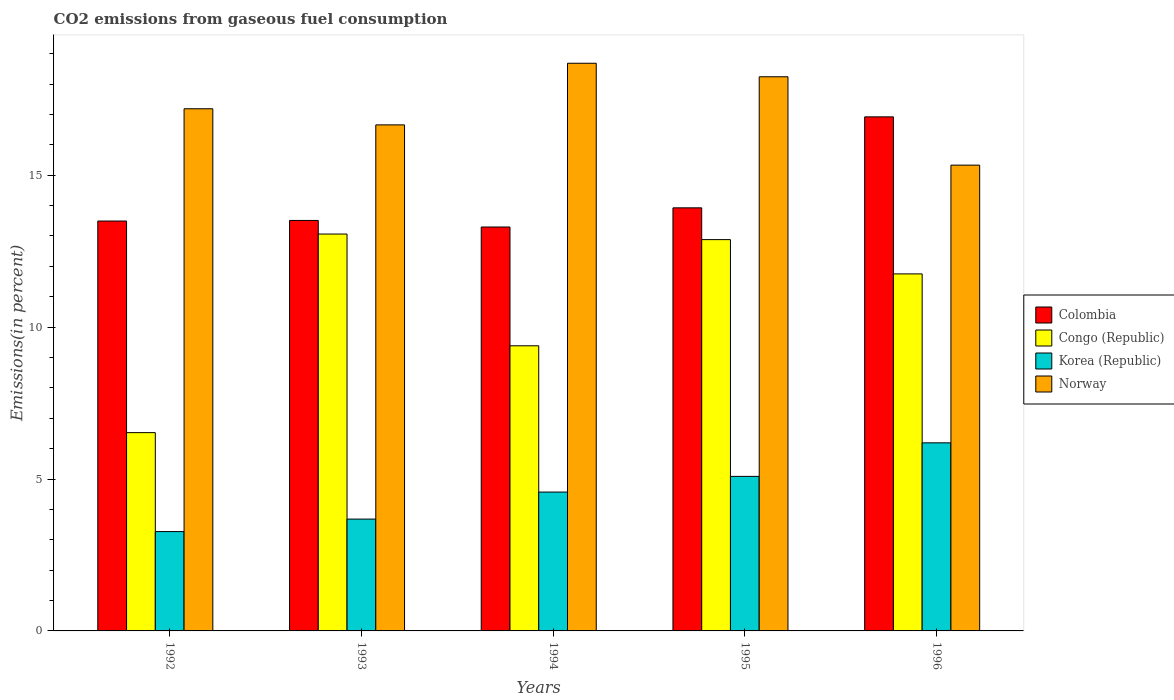How many groups of bars are there?
Provide a short and direct response. 5. Are the number of bars per tick equal to the number of legend labels?
Provide a short and direct response. Yes. How many bars are there on the 5th tick from the right?
Make the answer very short. 4. What is the total CO2 emitted in Congo (Republic) in 1995?
Provide a succinct answer. 12.88. Across all years, what is the maximum total CO2 emitted in Norway?
Offer a terse response. 18.69. Across all years, what is the minimum total CO2 emitted in Colombia?
Your response must be concise. 13.3. In which year was the total CO2 emitted in Norway maximum?
Give a very brief answer. 1994. What is the total total CO2 emitted in Korea (Republic) in the graph?
Your answer should be compact. 22.8. What is the difference between the total CO2 emitted in Colombia in 1992 and that in 1996?
Provide a short and direct response. -3.43. What is the difference between the total CO2 emitted in Korea (Republic) in 1996 and the total CO2 emitted in Colombia in 1994?
Your response must be concise. -7.1. What is the average total CO2 emitted in Colombia per year?
Make the answer very short. 14.23. In the year 1992, what is the difference between the total CO2 emitted in Congo (Republic) and total CO2 emitted in Colombia?
Your answer should be very brief. -6.97. What is the ratio of the total CO2 emitted in Norway in 1992 to that in 1995?
Ensure brevity in your answer.  0.94. What is the difference between the highest and the second highest total CO2 emitted in Congo (Republic)?
Ensure brevity in your answer.  0.18. What is the difference between the highest and the lowest total CO2 emitted in Norway?
Ensure brevity in your answer.  3.35. Is the sum of the total CO2 emitted in Congo (Republic) in 1992 and 1994 greater than the maximum total CO2 emitted in Korea (Republic) across all years?
Your answer should be compact. Yes. Is it the case that in every year, the sum of the total CO2 emitted in Colombia and total CO2 emitted in Norway is greater than the sum of total CO2 emitted in Korea (Republic) and total CO2 emitted in Congo (Republic)?
Your response must be concise. No. What does the 3rd bar from the left in 1994 represents?
Offer a terse response. Korea (Republic). What does the 2nd bar from the right in 1994 represents?
Provide a succinct answer. Korea (Republic). Is it the case that in every year, the sum of the total CO2 emitted in Congo (Republic) and total CO2 emitted in Korea (Republic) is greater than the total CO2 emitted in Norway?
Ensure brevity in your answer.  No. Does the graph contain any zero values?
Your answer should be very brief. No. Does the graph contain grids?
Your answer should be compact. No. Where does the legend appear in the graph?
Provide a succinct answer. Center right. How many legend labels are there?
Provide a short and direct response. 4. What is the title of the graph?
Your answer should be compact. CO2 emissions from gaseous fuel consumption. What is the label or title of the X-axis?
Provide a succinct answer. Years. What is the label or title of the Y-axis?
Offer a very short reply. Emissions(in percent). What is the Emissions(in percent) of Colombia in 1992?
Make the answer very short. 13.49. What is the Emissions(in percent) in Congo (Republic) in 1992?
Your answer should be compact. 6.53. What is the Emissions(in percent) in Korea (Republic) in 1992?
Offer a terse response. 3.27. What is the Emissions(in percent) of Norway in 1992?
Provide a succinct answer. 17.19. What is the Emissions(in percent) in Colombia in 1993?
Keep it short and to the point. 13.51. What is the Emissions(in percent) in Congo (Republic) in 1993?
Provide a succinct answer. 13.06. What is the Emissions(in percent) of Korea (Republic) in 1993?
Offer a very short reply. 3.68. What is the Emissions(in percent) in Norway in 1993?
Ensure brevity in your answer.  16.66. What is the Emissions(in percent) of Colombia in 1994?
Keep it short and to the point. 13.3. What is the Emissions(in percent) of Congo (Republic) in 1994?
Provide a succinct answer. 9.39. What is the Emissions(in percent) of Korea (Republic) in 1994?
Offer a terse response. 4.57. What is the Emissions(in percent) of Norway in 1994?
Your response must be concise. 18.69. What is the Emissions(in percent) of Colombia in 1995?
Provide a succinct answer. 13.93. What is the Emissions(in percent) of Congo (Republic) in 1995?
Your answer should be very brief. 12.88. What is the Emissions(in percent) of Korea (Republic) in 1995?
Keep it short and to the point. 5.09. What is the Emissions(in percent) of Norway in 1995?
Provide a short and direct response. 18.24. What is the Emissions(in percent) of Colombia in 1996?
Make the answer very short. 16.92. What is the Emissions(in percent) of Congo (Republic) in 1996?
Your answer should be compact. 11.75. What is the Emissions(in percent) in Korea (Republic) in 1996?
Provide a succinct answer. 6.19. What is the Emissions(in percent) in Norway in 1996?
Give a very brief answer. 15.33. Across all years, what is the maximum Emissions(in percent) in Colombia?
Keep it short and to the point. 16.92. Across all years, what is the maximum Emissions(in percent) of Congo (Republic)?
Ensure brevity in your answer.  13.06. Across all years, what is the maximum Emissions(in percent) of Korea (Republic)?
Make the answer very short. 6.19. Across all years, what is the maximum Emissions(in percent) of Norway?
Make the answer very short. 18.69. Across all years, what is the minimum Emissions(in percent) in Colombia?
Give a very brief answer. 13.3. Across all years, what is the minimum Emissions(in percent) of Congo (Republic)?
Offer a terse response. 6.53. Across all years, what is the minimum Emissions(in percent) in Korea (Republic)?
Provide a succinct answer. 3.27. Across all years, what is the minimum Emissions(in percent) of Norway?
Offer a terse response. 15.33. What is the total Emissions(in percent) of Colombia in the graph?
Give a very brief answer. 71.15. What is the total Emissions(in percent) in Congo (Republic) in the graph?
Make the answer very short. 53.61. What is the total Emissions(in percent) in Korea (Republic) in the graph?
Give a very brief answer. 22.8. What is the total Emissions(in percent) in Norway in the graph?
Provide a short and direct response. 86.1. What is the difference between the Emissions(in percent) in Colombia in 1992 and that in 1993?
Your answer should be compact. -0.02. What is the difference between the Emissions(in percent) in Congo (Republic) in 1992 and that in 1993?
Give a very brief answer. -6.54. What is the difference between the Emissions(in percent) in Korea (Republic) in 1992 and that in 1993?
Provide a succinct answer. -0.41. What is the difference between the Emissions(in percent) in Norway in 1992 and that in 1993?
Offer a very short reply. 0.53. What is the difference between the Emissions(in percent) of Colombia in 1992 and that in 1994?
Your answer should be compact. 0.2. What is the difference between the Emissions(in percent) in Congo (Republic) in 1992 and that in 1994?
Keep it short and to the point. -2.86. What is the difference between the Emissions(in percent) of Korea (Republic) in 1992 and that in 1994?
Your response must be concise. -1.3. What is the difference between the Emissions(in percent) in Norway in 1992 and that in 1994?
Ensure brevity in your answer.  -1.5. What is the difference between the Emissions(in percent) of Colombia in 1992 and that in 1995?
Ensure brevity in your answer.  -0.43. What is the difference between the Emissions(in percent) of Congo (Republic) in 1992 and that in 1995?
Provide a succinct answer. -6.35. What is the difference between the Emissions(in percent) in Korea (Republic) in 1992 and that in 1995?
Ensure brevity in your answer.  -1.82. What is the difference between the Emissions(in percent) in Norway in 1992 and that in 1995?
Your answer should be compact. -1.05. What is the difference between the Emissions(in percent) of Colombia in 1992 and that in 1996?
Your answer should be compact. -3.43. What is the difference between the Emissions(in percent) in Congo (Republic) in 1992 and that in 1996?
Offer a terse response. -5.23. What is the difference between the Emissions(in percent) of Korea (Republic) in 1992 and that in 1996?
Make the answer very short. -2.92. What is the difference between the Emissions(in percent) in Norway in 1992 and that in 1996?
Give a very brief answer. 1.86. What is the difference between the Emissions(in percent) of Colombia in 1993 and that in 1994?
Keep it short and to the point. 0.22. What is the difference between the Emissions(in percent) in Congo (Republic) in 1993 and that in 1994?
Provide a succinct answer. 3.68. What is the difference between the Emissions(in percent) of Korea (Republic) in 1993 and that in 1994?
Offer a terse response. -0.89. What is the difference between the Emissions(in percent) of Norway in 1993 and that in 1994?
Offer a terse response. -2.03. What is the difference between the Emissions(in percent) in Colombia in 1993 and that in 1995?
Make the answer very short. -0.41. What is the difference between the Emissions(in percent) of Congo (Republic) in 1993 and that in 1995?
Provide a succinct answer. 0.18. What is the difference between the Emissions(in percent) of Korea (Republic) in 1993 and that in 1995?
Ensure brevity in your answer.  -1.41. What is the difference between the Emissions(in percent) in Norway in 1993 and that in 1995?
Provide a succinct answer. -1.58. What is the difference between the Emissions(in percent) in Colombia in 1993 and that in 1996?
Provide a succinct answer. -3.41. What is the difference between the Emissions(in percent) in Congo (Republic) in 1993 and that in 1996?
Make the answer very short. 1.31. What is the difference between the Emissions(in percent) in Korea (Republic) in 1993 and that in 1996?
Your answer should be very brief. -2.51. What is the difference between the Emissions(in percent) in Norway in 1993 and that in 1996?
Keep it short and to the point. 1.32. What is the difference between the Emissions(in percent) of Colombia in 1994 and that in 1995?
Offer a terse response. -0.63. What is the difference between the Emissions(in percent) of Congo (Republic) in 1994 and that in 1995?
Provide a succinct answer. -3.49. What is the difference between the Emissions(in percent) in Korea (Republic) in 1994 and that in 1995?
Offer a very short reply. -0.52. What is the difference between the Emissions(in percent) in Norway in 1994 and that in 1995?
Offer a terse response. 0.44. What is the difference between the Emissions(in percent) in Colombia in 1994 and that in 1996?
Your response must be concise. -3.63. What is the difference between the Emissions(in percent) in Congo (Republic) in 1994 and that in 1996?
Your answer should be very brief. -2.37. What is the difference between the Emissions(in percent) of Korea (Republic) in 1994 and that in 1996?
Your answer should be compact. -1.62. What is the difference between the Emissions(in percent) in Norway in 1994 and that in 1996?
Provide a succinct answer. 3.35. What is the difference between the Emissions(in percent) in Colombia in 1995 and that in 1996?
Your answer should be very brief. -2.99. What is the difference between the Emissions(in percent) in Congo (Republic) in 1995 and that in 1996?
Give a very brief answer. 1.13. What is the difference between the Emissions(in percent) of Korea (Republic) in 1995 and that in 1996?
Keep it short and to the point. -1.1. What is the difference between the Emissions(in percent) in Norway in 1995 and that in 1996?
Provide a succinct answer. 2.91. What is the difference between the Emissions(in percent) in Colombia in 1992 and the Emissions(in percent) in Congo (Republic) in 1993?
Keep it short and to the point. 0.43. What is the difference between the Emissions(in percent) of Colombia in 1992 and the Emissions(in percent) of Korea (Republic) in 1993?
Offer a terse response. 9.81. What is the difference between the Emissions(in percent) in Colombia in 1992 and the Emissions(in percent) in Norway in 1993?
Your response must be concise. -3.17. What is the difference between the Emissions(in percent) in Congo (Republic) in 1992 and the Emissions(in percent) in Korea (Republic) in 1993?
Provide a short and direct response. 2.85. What is the difference between the Emissions(in percent) in Congo (Republic) in 1992 and the Emissions(in percent) in Norway in 1993?
Provide a short and direct response. -10.13. What is the difference between the Emissions(in percent) of Korea (Republic) in 1992 and the Emissions(in percent) of Norway in 1993?
Keep it short and to the point. -13.39. What is the difference between the Emissions(in percent) of Colombia in 1992 and the Emissions(in percent) of Congo (Republic) in 1994?
Provide a succinct answer. 4.11. What is the difference between the Emissions(in percent) of Colombia in 1992 and the Emissions(in percent) of Korea (Republic) in 1994?
Your response must be concise. 8.92. What is the difference between the Emissions(in percent) in Colombia in 1992 and the Emissions(in percent) in Norway in 1994?
Your response must be concise. -5.19. What is the difference between the Emissions(in percent) of Congo (Republic) in 1992 and the Emissions(in percent) of Korea (Republic) in 1994?
Make the answer very short. 1.96. What is the difference between the Emissions(in percent) of Congo (Republic) in 1992 and the Emissions(in percent) of Norway in 1994?
Your answer should be compact. -12.16. What is the difference between the Emissions(in percent) in Korea (Republic) in 1992 and the Emissions(in percent) in Norway in 1994?
Give a very brief answer. -15.42. What is the difference between the Emissions(in percent) of Colombia in 1992 and the Emissions(in percent) of Congo (Republic) in 1995?
Provide a succinct answer. 0.61. What is the difference between the Emissions(in percent) of Colombia in 1992 and the Emissions(in percent) of Korea (Republic) in 1995?
Offer a terse response. 8.41. What is the difference between the Emissions(in percent) of Colombia in 1992 and the Emissions(in percent) of Norway in 1995?
Make the answer very short. -4.75. What is the difference between the Emissions(in percent) in Congo (Republic) in 1992 and the Emissions(in percent) in Korea (Republic) in 1995?
Offer a terse response. 1.44. What is the difference between the Emissions(in percent) in Congo (Republic) in 1992 and the Emissions(in percent) in Norway in 1995?
Provide a succinct answer. -11.71. What is the difference between the Emissions(in percent) in Korea (Republic) in 1992 and the Emissions(in percent) in Norway in 1995?
Offer a terse response. -14.97. What is the difference between the Emissions(in percent) in Colombia in 1992 and the Emissions(in percent) in Congo (Republic) in 1996?
Ensure brevity in your answer.  1.74. What is the difference between the Emissions(in percent) of Colombia in 1992 and the Emissions(in percent) of Korea (Republic) in 1996?
Your answer should be compact. 7.3. What is the difference between the Emissions(in percent) of Colombia in 1992 and the Emissions(in percent) of Norway in 1996?
Provide a succinct answer. -1.84. What is the difference between the Emissions(in percent) of Congo (Republic) in 1992 and the Emissions(in percent) of Korea (Republic) in 1996?
Give a very brief answer. 0.34. What is the difference between the Emissions(in percent) in Congo (Republic) in 1992 and the Emissions(in percent) in Norway in 1996?
Provide a succinct answer. -8.81. What is the difference between the Emissions(in percent) of Korea (Republic) in 1992 and the Emissions(in percent) of Norway in 1996?
Your answer should be very brief. -12.06. What is the difference between the Emissions(in percent) of Colombia in 1993 and the Emissions(in percent) of Congo (Republic) in 1994?
Ensure brevity in your answer.  4.13. What is the difference between the Emissions(in percent) of Colombia in 1993 and the Emissions(in percent) of Korea (Republic) in 1994?
Make the answer very short. 8.94. What is the difference between the Emissions(in percent) in Colombia in 1993 and the Emissions(in percent) in Norway in 1994?
Provide a short and direct response. -5.17. What is the difference between the Emissions(in percent) of Congo (Republic) in 1993 and the Emissions(in percent) of Korea (Republic) in 1994?
Provide a succinct answer. 8.49. What is the difference between the Emissions(in percent) of Congo (Republic) in 1993 and the Emissions(in percent) of Norway in 1994?
Ensure brevity in your answer.  -5.62. What is the difference between the Emissions(in percent) of Korea (Republic) in 1993 and the Emissions(in percent) of Norway in 1994?
Your response must be concise. -15. What is the difference between the Emissions(in percent) of Colombia in 1993 and the Emissions(in percent) of Congo (Republic) in 1995?
Provide a short and direct response. 0.63. What is the difference between the Emissions(in percent) of Colombia in 1993 and the Emissions(in percent) of Korea (Republic) in 1995?
Your answer should be compact. 8.42. What is the difference between the Emissions(in percent) in Colombia in 1993 and the Emissions(in percent) in Norway in 1995?
Your answer should be compact. -4.73. What is the difference between the Emissions(in percent) in Congo (Republic) in 1993 and the Emissions(in percent) in Korea (Republic) in 1995?
Offer a very short reply. 7.98. What is the difference between the Emissions(in percent) in Congo (Republic) in 1993 and the Emissions(in percent) in Norway in 1995?
Give a very brief answer. -5.18. What is the difference between the Emissions(in percent) in Korea (Republic) in 1993 and the Emissions(in percent) in Norway in 1995?
Give a very brief answer. -14.56. What is the difference between the Emissions(in percent) in Colombia in 1993 and the Emissions(in percent) in Congo (Republic) in 1996?
Your answer should be very brief. 1.76. What is the difference between the Emissions(in percent) in Colombia in 1993 and the Emissions(in percent) in Korea (Republic) in 1996?
Provide a short and direct response. 7.32. What is the difference between the Emissions(in percent) of Colombia in 1993 and the Emissions(in percent) of Norway in 1996?
Your answer should be very brief. -1.82. What is the difference between the Emissions(in percent) in Congo (Republic) in 1993 and the Emissions(in percent) in Korea (Republic) in 1996?
Your response must be concise. 6.87. What is the difference between the Emissions(in percent) in Congo (Republic) in 1993 and the Emissions(in percent) in Norway in 1996?
Ensure brevity in your answer.  -2.27. What is the difference between the Emissions(in percent) of Korea (Republic) in 1993 and the Emissions(in percent) of Norway in 1996?
Provide a short and direct response. -11.65. What is the difference between the Emissions(in percent) of Colombia in 1994 and the Emissions(in percent) of Congo (Republic) in 1995?
Ensure brevity in your answer.  0.42. What is the difference between the Emissions(in percent) of Colombia in 1994 and the Emissions(in percent) of Korea (Republic) in 1995?
Offer a very short reply. 8.21. What is the difference between the Emissions(in percent) in Colombia in 1994 and the Emissions(in percent) in Norway in 1995?
Your answer should be very brief. -4.95. What is the difference between the Emissions(in percent) of Congo (Republic) in 1994 and the Emissions(in percent) of Korea (Republic) in 1995?
Offer a terse response. 4.3. What is the difference between the Emissions(in percent) in Congo (Republic) in 1994 and the Emissions(in percent) in Norway in 1995?
Keep it short and to the point. -8.86. What is the difference between the Emissions(in percent) in Korea (Republic) in 1994 and the Emissions(in percent) in Norway in 1995?
Your answer should be very brief. -13.67. What is the difference between the Emissions(in percent) of Colombia in 1994 and the Emissions(in percent) of Congo (Republic) in 1996?
Your response must be concise. 1.54. What is the difference between the Emissions(in percent) in Colombia in 1994 and the Emissions(in percent) in Korea (Republic) in 1996?
Keep it short and to the point. 7.1. What is the difference between the Emissions(in percent) in Colombia in 1994 and the Emissions(in percent) in Norway in 1996?
Make the answer very short. -2.04. What is the difference between the Emissions(in percent) in Congo (Republic) in 1994 and the Emissions(in percent) in Korea (Republic) in 1996?
Ensure brevity in your answer.  3.19. What is the difference between the Emissions(in percent) of Congo (Republic) in 1994 and the Emissions(in percent) of Norway in 1996?
Offer a terse response. -5.95. What is the difference between the Emissions(in percent) of Korea (Republic) in 1994 and the Emissions(in percent) of Norway in 1996?
Provide a short and direct response. -10.76. What is the difference between the Emissions(in percent) in Colombia in 1995 and the Emissions(in percent) in Congo (Republic) in 1996?
Give a very brief answer. 2.17. What is the difference between the Emissions(in percent) in Colombia in 1995 and the Emissions(in percent) in Korea (Republic) in 1996?
Provide a succinct answer. 7.74. What is the difference between the Emissions(in percent) of Colombia in 1995 and the Emissions(in percent) of Norway in 1996?
Your answer should be very brief. -1.41. What is the difference between the Emissions(in percent) of Congo (Republic) in 1995 and the Emissions(in percent) of Korea (Republic) in 1996?
Offer a very short reply. 6.69. What is the difference between the Emissions(in percent) in Congo (Republic) in 1995 and the Emissions(in percent) in Norway in 1996?
Offer a very short reply. -2.45. What is the difference between the Emissions(in percent) of Korea (Republic) in 1995 and the Emissions(in percent) of Norway in 1996?
Make the answer very short. -10.25. What is the average Emissions(in percent) in Colombia per year?
Your answer should be very brief. 14.23. What is the average Emissions(in percent) in Congo (Republic) per year?
Provide a succinct answer. 10.72. What is the average Emissions(in percent) in Korea (Republic) per year?
Keep it short and to the point. 4.56. What is the average Emissions(in percent) of Norway per year?
Give a very brief answer. 17.22. In the year 1992, what is the difference between the Emissions(in percent) in Colombia and Emissions(in percent) in Congo (Republic)?
Make the answer very short. 6.97. In the year 1992, what is the difference between the Emissions(in percent) of Colombia and Emissions(in percent) of Korea (Republic)?
Make the answer very short. 10.22. In the year 1992, what is the difference between the Emissions(in percent) in Colombia and Emissions(in percent) in Norway?
Keep it short and to the point. -3.7. In the year 1992, what is the difference between the Emissions(in percent) of Congo (Republic) and Emissions(in percent) of Korea (Republic)?
Provide a short and direct response. 3.26. In the year 1992, what is the difference between the Emissions(in percent) in Congo (Republic) and Emissions(in percent) in Norway?
Your answer should be very brief. -10.66. In the year 1992, what is the difference between the Emissions(in percent) of Korea (Republic) and Emissions(in percent) of Norway?
Give a very brief answer. -13.92. In the year 1993, what is the difference between the Emissions(in percent) in Colombia and Emissions(in percent) in Congo (Republic)?
Offer a terse response. 0.45. In the year 1993, what is the difference between the Emissions(in percent) of Colombia and Emissions(in percent) of Korea (Republic)?
Make the answer very short. 9.83. In the year 1993, what is the difference between the Emissions(in percent) of Colombia and Emissions(in percent) of Norway?
Offer a terse response. -3.15. In the year 1993, what is the difference between the Emissions(in percent) in Congo (Republic) and Emissions(in percent) in Korea (Republic)?
Make the answer very short. 9.38. In the year 1993, what is the difference between the Emissions(in percent) in Congo (Republic) and Emissions(in percent) in Norway?
Your answer should be very brief. -3.59. In the year 1993, what is the difference between the Emissions(in percent) of Korea (Republic) and Emissions(in percent) of Norway?
Provide a succinct answer. -12.98. In the year 1994, what is the difference between the Emissions(in percent) in Colombia and Emissions(in percent) in Congo (Republic)?
Give a very brief answer. 3.91. In the year 1994, what is the difference between the Emissions(in percent) of Colombia and Emissions(in percent) of Korea (Republic)?
Give a very brief answer. 8.73. In the year 1994, what is the difference between the Emissions(in percent) in Colombia and Emissions(in percent) in Norway?
Your answer should be compact. -5.39. In the year 1994, what is the difference between the Emissions(in percent) in Congo (Republic) and Emissions(in percent) in Korea (Republic)?
Your answer should be compact. 4.82. In the year 1994, what is the difference between the Emissions(in percent) of Congo (Republic) and Emissions(in percent) of Norway?
Provide a succinct answer. -9.3. In the year 1994, what is the difference between the Emissions(in percent) in Korea (Republic) and Emissions(in percent) in Norway?
Offer a terse response. -14.12. In the year 1995, what is the difference between the Emissions(in percent) of Colombia and Emissions(in percent) of Congo (Republic)?
Give a very brief answer. 1.05. In the year 1995, what is the difference between the Emissions(in percent) in Colombia and Emissions(in percent) in Korea (Republic)?
Keep it short and to the point. 8.84. In the year 1995, what is the difference between the Emissions(in percent) in Colombia and Emissions(in percent) in Norway?
Provide a succinct answer. -4.31. In the year 1995, what is the difference between the Emissions(in percent) in Congo (Republic) and Emissions(in percent) in Korea (Republic)?
Ensure brevity in your answer.  7.79. In the year 1995, what is the difference between the Emissions(in percent) of Congo (Republic) and Emissions(in percent) of Norway?
Keep it short and to the point. -5.36. In the year 1995, what is the difference between the Emissions(in percent) of Korea (Republic) and Emissions(in percent) of Norway?
Give a very brief answer. -13.15. In the year 1996, what is the difference between the Emissions(in percent) in Colombia and Emissions(in percent) in Congo (Republic)?
Your answer should be compact. 5.17. In the year 1996, what is the difference between the Emissions(in percent) of Colombia and Emissions(in percent) of Korea (Republic)?
Provide a short and direct response. 10.73. In the year 1996, what is the difference between the Emissions(in percent) in Colombia and Emissions(in percent) in Norway?
Provide a short and direct response. 1.59. In the year 1996, what is the difference between the Emissions(in percent) of Congo (Republic) and Emissions(in percent) of Korea (Republic)?
Offer a terse response. 5.56. In the year 1996, what is the difference between the Emissions(in percent) in Congo (Republic) and Emissions(in percent) in Norway?
Your response must be concise. -3.58. In the year 1996, what is the difference between the Emissions(in percent) of Korea (Republic) and Emissions(in percent) of Norway?
Your answer should be compact. -9.14. What is the ratio of the Emissions(in percent) of Colombia in 1992 to that in 1993?
Keep it short and to the point. 1. What is the ratio of the Emissions(in percent) in Congo (Republic) in 1992 to that in 1993?
Your answer should be very brief. 0.5. What is the ratio of the Emissions(in percent) of Korea (Republic) in 1992 to that in 1993?
Provide a succinct answer. 0.89. What is the ratio of the Emissions(in percent) of Norway in 1992 to that in 1993?
Provide a short and direct response. 1.03. What is the ratio of the Emissions(in percent) in Colombia in 1992 to that in 1994?
Give a very brief answer. 1.01. What is the ratio of the Emissions(in percent) in Congo (Republic) in 1992 to that in 1994?
Provide a short and direct response. 0.7. What is the ratio of the Emissions(in percent) in Korea (Republic) in 1992 to that in 1994?
Make the answer very short. 0.72. What is the ratio of the Emissions(in percent) in Norway in 1992 to that in 1994?
Your answer should be very brief. 0.92. What is the ratio of the Emissions(in percent) in Colombia in 1992 to that in 1995?
Offer a very short reply. 0.97. What is the ratio of the Emissions(in percent) of Congo (Republic) in 1992 to that in 1995?
Keep it short and to the point. 0.51. What is the ratio of the Emissions(in percent) in Korea (Republic) in 1992 to that in 1995?
Offer a very short reply. 0.64. What is the ratio of the Emissions(in percent) of Norway in 1992 to that in 1995?
Offer a very short reply. 0.94. What is the ratio of the Emissions(in percent) of Colombia in 1992 to that in 1996?
Keep it short and to the point. 0.8. What is the ratio of the Emissions(in percent) of Congo (Republic) in 1992 to that in 1996?
Give a very brief answer. 0.56. What is the ratio of the Emissions(in percent) in Korea (Republic) in 1992 to that in 1996?
Give a very brief answer. 0.53. What is the ratio of the Emissions(in percent) of Norway in 1992 to that in 1996?
Your answer should be very brief. 1.12. What is the ratio of the Emissions(in percent) of Colombia in 1993 to that in 1994?
Your answer should be compact. 1.02. What is the ratio of the Emissions(in percent) of Congo (Republic) in 1993 to that in 1994?
Keep it short and to the point. 1.39. What is the ratio of the Emissions(in percent) in Korea (Republic) in 1993 to that in 1994?
Ensure brevity in your answer.  0.81. What is the ratio of the Emissions(in percent) of Norway in 1993 to that in 1994?
Offer a very short reply. 0.89. What is the ratio of the Emissions(in percent) of Colombia in 1993 to that in 1995?
Provide a succinct answer. 0.97. What is the ratio of the Emissions(in percent) in Congo (Republic) in 1993 to that in 1995?
Make the answer very short. 1.01. What is the ratio of the Emissions(in percent) of Korea (Republic) in 1993 to that in 1995?
Provide a succinct answer. 0.72. What is the ratio of the Emissions(in percent) of Norway in 1993 to that in 1995?
Provide a succinct answer. 0.91. What is the ratio of the Emissions(in percent) of Colombia in 1993 to that in 1996?
Offer a terse response. 0.8. What is the ratio of the Emissions(in percent) in Congo (Republic) in 1993 to that in 1996?
Your answer should be compact. 1.11. What is the ratio of the Emissions(in percent) in Korea (Republic) in 1993 to that in 1996?
Offer a very short reply. 0.59. What is the ratio of the Emissions(in percent) in Norway in 1993 to that in 1996?
Give a very brief answer. 1.09. What is the ratio of the Emissions(in percent) of Colombia in 1994 to that in 1995?
Ensure brevity in your answer.  0.95. What is the ratio of the Emissions(in percent) of Congo (Republic) in 1994 to that in 1995?
Your response must be concise. 0.73. What is the ratio of the Emissions(in percent) of Korea (Republic) in 1994 to that in 1995?
Keep it short and to the point. 0.9. What is the ratio of the Emissions(in percent) of Norway in 1994 to that in 1995?
Keep it short and to the point. 1.02. What is the ratio of the Emissions(in percent) in Colombia in 1994 to that in 1996?
Offer a very short reply. 0.79. What is the ratio of the Emissions(in percent) of Congo (Republic) in 1994 to that in 1996?
Provide a short and direct response. 0.8. What is the ratio of the Emissions(in percent) of Korea (Republic) in 1994 to that in 1996?
Provide a succinct answer. 0.74. What is the ratio of the Emissions(in percent) in Norway in 1994 to that in 1996?
Provide a succinct answer. 1.22. What is the ratio of the Emissions(in percent) of Colombia in 1995 to that in 1996?
Your answer should be very brief. 0.82. What is the ratio of the Emissions(in percent) in Congo (Republic) in 1995 to that in 1996?
Provide a succinct answer. 1.1. What is the ratio of the Emissions(in percent) in Korea (Republic) in 1995 to that in 1996?
Offer a terse response. 0.82. What is the ratio of the Emissions(in percent) of Norway in 1995 to that in 1996?
Your answer should be very brief. 1.19. What is the difference between the highest and the second highest Emissions(in percent) in Colombia?
Keep it short and to the point. 2.99. What is the difference between the highest and the second highest Emissions(in percent) of Congo (Republic)?
Make the answer very short. 0.18. What is the difference between the highest and the second highest Emissions(in percent) in Korea (Republic)?
Your answer should be very brief. 1.1. What is the difference between the highest and the second highest Emissions(in percent) of Norway?
Your response must be concise. 0.44. What is the difference between the highest and the lowest Emissions(in percent) of Colombia?
Provide a short and direct response. 3.63. What is the difference between the highest and the lowest Emissions(in percent) in Congo (Republic)?
Your response must be concise. 6.54. What is the difference between the highest and the lowest Emissions(in percent) of Korea (Republic)?
Offer a very short reply. 2.92. What is the difference between the highest and the lowest Emissions(in percent) of Norway?
Offer a very short reply. 3.35. 